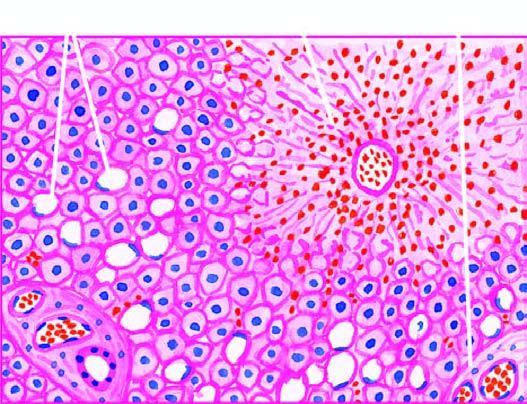does the vesselwall show mild fatty change of liver cells?
Answer the question using a single word or phrase. No 